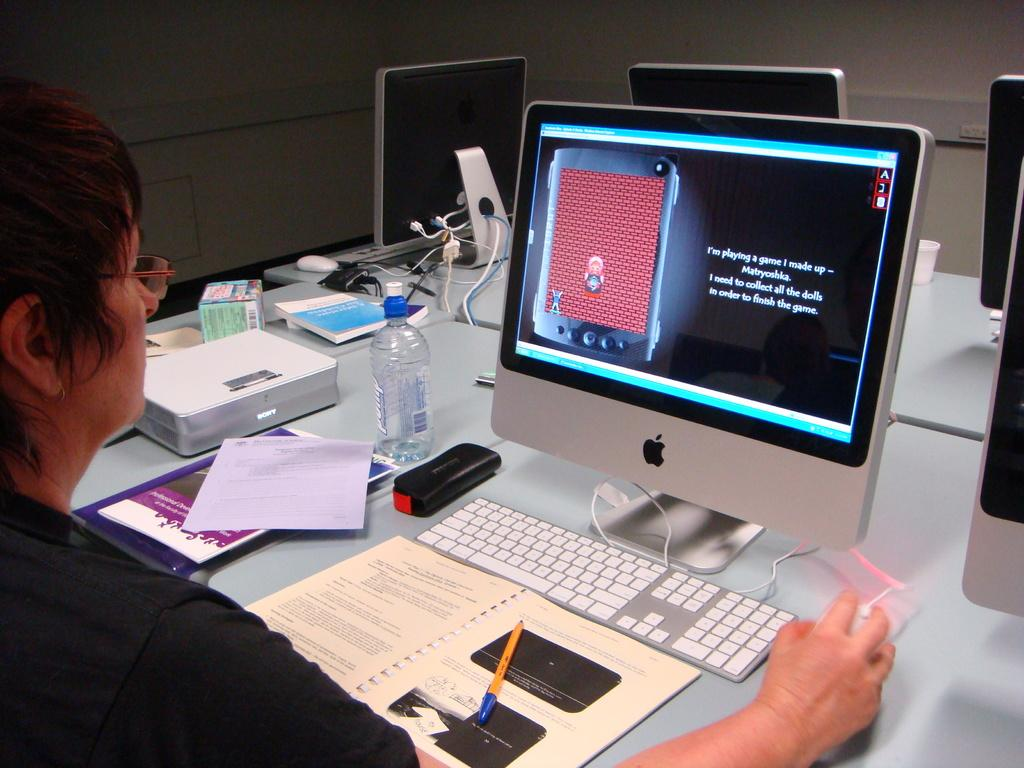<image>
Write a terse but informative summary of the picture. A person sitting in front of a computer screen which reads 'I'm playing a game I made up' 